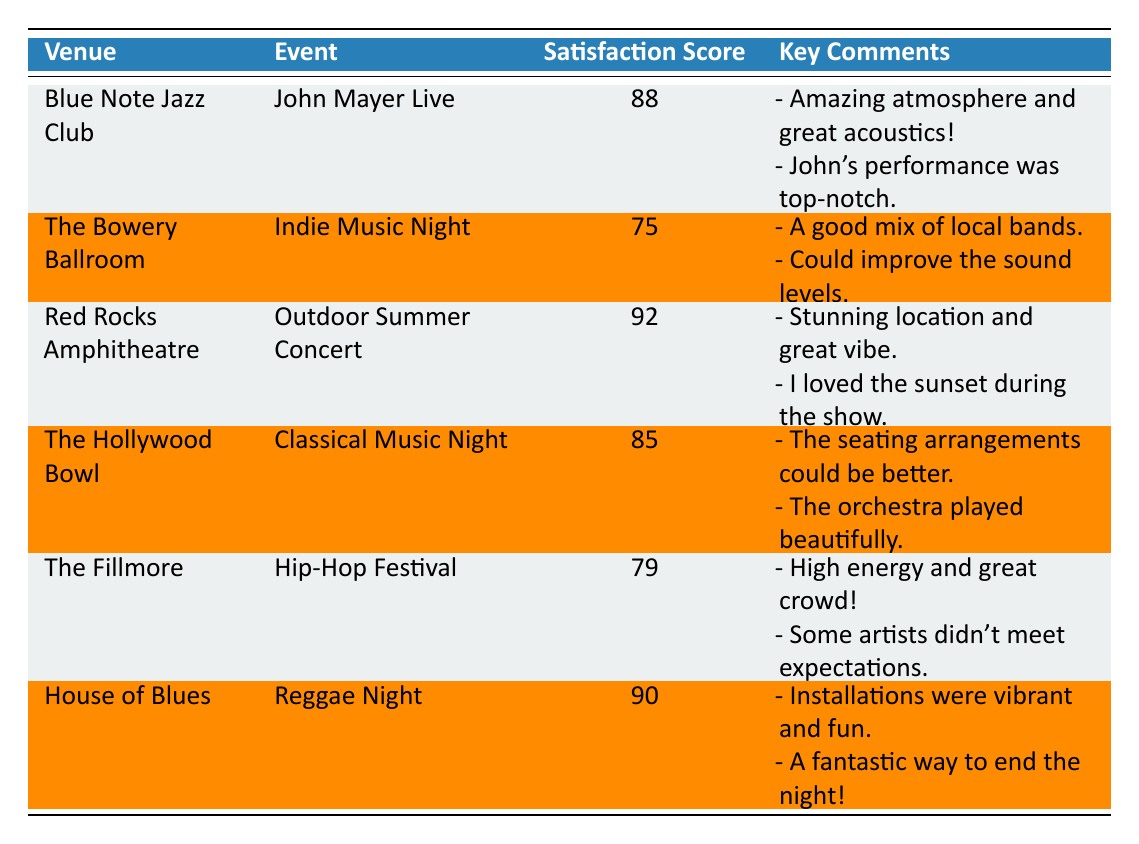What is the satisfaction score for the event at the Blue Note Jazz Club? The table shows the satisfaction score for the event "John Mayer Live" held at the Blue Note Jazz Club, which is listed as 88.
Answer: 88 Which venue received the highest satisfaction score? By comparing the satisfaction scores, Red Rocks Amphitheatre has the highest score of 92 for the "Outdoor Summer Concert".
Answer: Red Rocks Amphitheatre What is the average satisfaction score across all events? To find the average, sum the scores: (88 + 75 + 92 + 85 + 79 + 90) = 509. There are 6 events, so the average score is 509 / 6 = 84.83.
Answer: 84.83 Did any event score below 80? The table indicates that The Bowery Ballroom with a score of 75 and The Fillmore with a score of 79 both scored below 80.
Answer: Yes Which event had comments about the seating arrangements? The Hollywood Bowl event "Classical Music Night" includes a comment mentioning that “the seating arrangements could be better.”
Answer: Classical Music Night What is the satisfaction score difference between the highest and lowest scoring events? The highest score is 92 (Red Rocks Amphitheatre) and the lowest score is 75 (The Bowery Ballroom). The difference is 92 - 75 = 17.
Answer: 17 How many events received scores of 85 or higher? The events with scores of 85 or higher are "John Mayer Live" (88), "Outdoor Summer Concert" (92), "Classical Music Night" (85), and "Reggae Night" (90). This totals 4 events.
Answer: 4 What type of music event at the House of Blues received positive comments? The House of Blues hosted "Reggae Night," which received positive comments, including "Installations were vibrant and fun."
Answer: Reggae Night Is there any mention of the outdoor experience in the comments? The comments for the Red Rocks Amphitheatre event mention a "stunning location and great vibe" as well as "the sunset during the show," indicating a positive outdoor experience.
Answer: Yes 